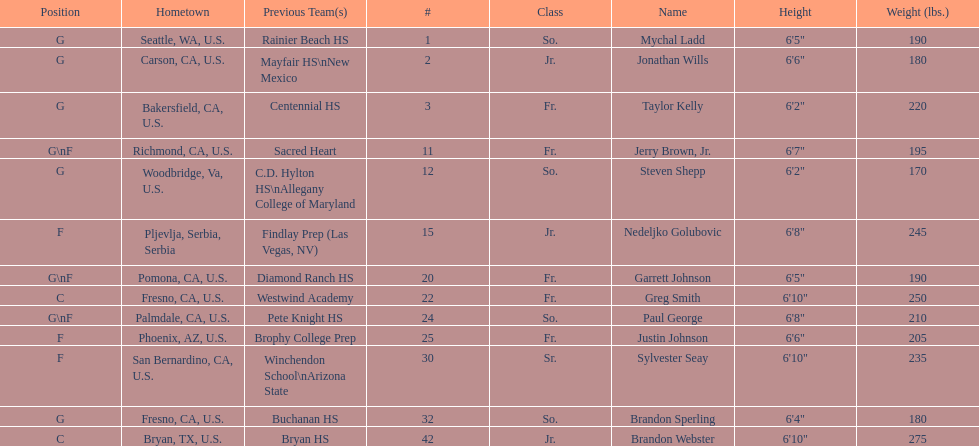Who is the only player not from the u. s.? Nedeljko Golubovic. 